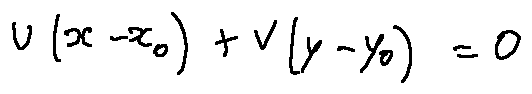Convert formula to latex. <formula><loc_0><loc_0><loc_500><loc_500>u ( x - x _ { 0 } ) + v ( y - y _ { 0 } ) = 0</formula> 